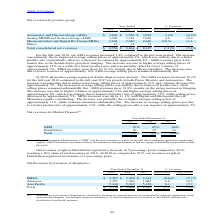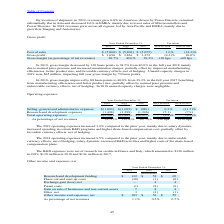According to Stmicroelectronics's financial document, In 2019, how much revenue grew in Americas? According to the financial document, 6.8%. The relevant text states: "By location of shipment, in 2019, revenues grew 6.8% in Americas, driven by Power Discrete, remained substantially flat in Asia and decreased 8.6% in EME..." Also, In 2019, why did the revenue grew in Americas? driven by Power Discrete. The document states: "hipment, in 2019, revenues grew 6.8% in Americas, driven by Power Discrete, remained substantially flat in Asia and decreased 8.6% in EMEA, mainly due..." Also, In 2018,why did the revenues grew across all regions? mainly due to growth in Imaging and Automotive.. The document states: "across all regions, led by Asia Pacific and EMEA, mainly due to growth in Imaging and Automotive...." Also, can you calculate: What are the average net revenues by EMEA for Year Ended December 31? To answer this question, I need to perform calculations using the financial data. The calculation is: (2,265+2,478+2,142) / 3, which equals 2295 (in millions). This is based on the information: "EMEA $ 2,265 $ 2,478 $ 2,142 (8.6)% 15.7% EMEA $ 2,265 $ 2,478 $ 2,142 (8.6)% 15.7% EMEA $ 2,265 $ 2,478 $ 2,142 (8.6)% 15.7%..." The key data points involved are: 2,142, 2,265, 2,478. Also, can you calculate: What are the average net revenues by Americas for Year Ended December 31? To answer this question, I need to perform calculations using the financial data. The calculation is: (1,351+1,264+1,085) / 3, which equals 1233.33 (in millions). This is based on the information: "Americas 1,351 1,264 1,085 6.8 16.5 Americas 1,351 1,264 1,085 6.8 16.5 Americas 1,351 1,264 1,085 6.8 16.5..." The key data points involved are: 1,085, 1,264, 1,351. Also, can you calculate: What are the average net revenues by Asia Pacific for Year Ended December 31? To answer this question, I need to perform calculations using the financial data. The calculation is: (5,940+5,922+5,120) / 3, which equals 5660.67 (in millions). This is based on the information: "Asia Pacific 5,940 5,922 5,120 0.3 15.7 Asia Pacific 5,940 5,922 5,120 0.3 15.7 Asia Pacific 5,940 5,922 5,120 0.3 15.7..." The key data points involved are: 5,120, 5,922, 5,940. 